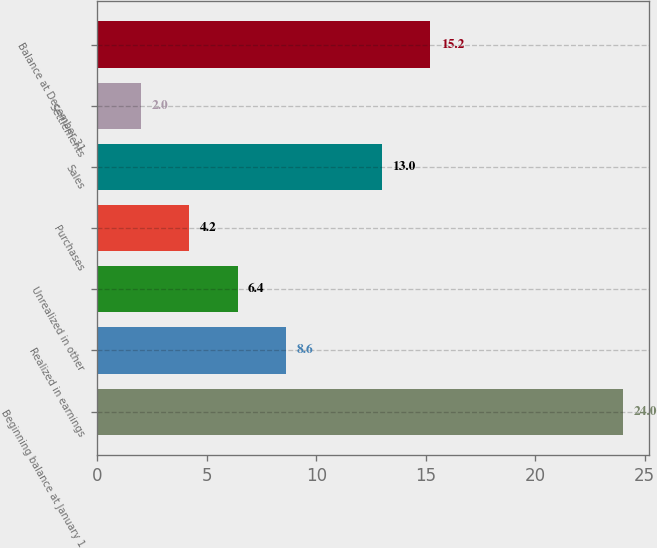Convert chart. <chart><loc_0><loc_0><loc_500><loc_500><bar_chart><fcel>Beginning balance at January 1<fcel>Realized in earnings<fcel>Unrealized in other<fcel>Purchases<fcel>Sales<fcel>Settlements<fcel>Balance at December 31<nl><fcel>24<fcel>8.6<fcel>6.4<fcel>4.2<fcel>13<fcel>2<fcel>15.2<nl></chart> 